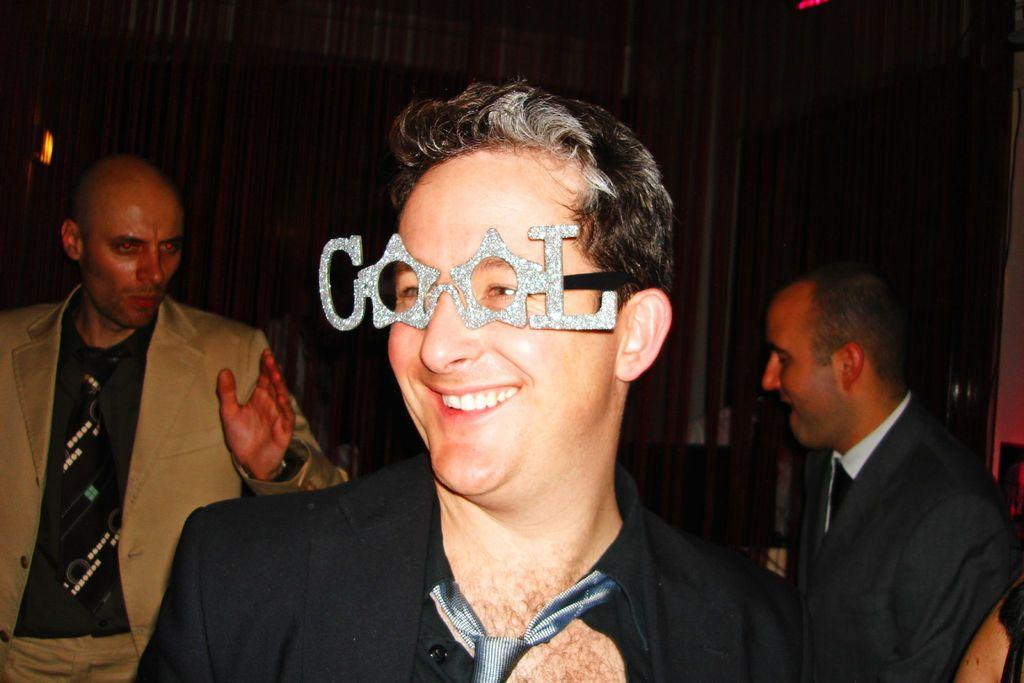What is the facial expression of the person in the image? The person in the image has a smile on his face. What is the person wearing that is unique or decorative? The person is wearing decorative eyewear. How many other people are visible in the image? There are two other people behind the first person. What can be seen in the background of the image? There is a wall visible in the background of the image. What type of fish is swimming in the background of the image? There is no fish present in the image; it features a person with a smile and decorative eyewear, along with two other people and a wall in the background. 